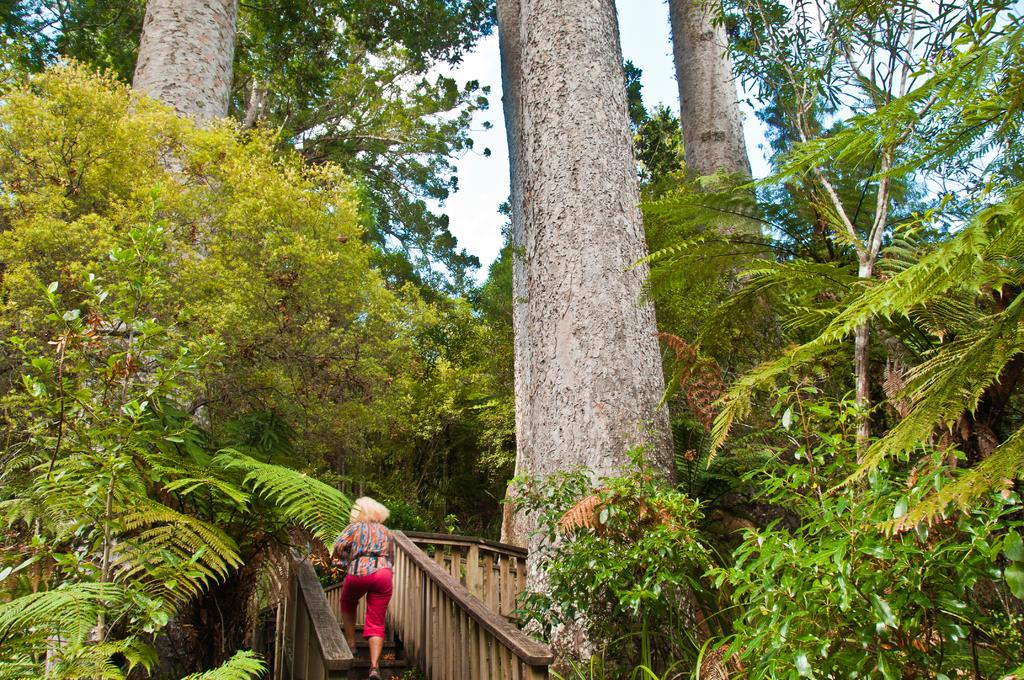What type of natural elements can be seen in the image? There are trees in the image. What is the woman in the image doing? The woman is climbing wooden stairs in the image. How would you describe the weather in the image? The sky is cloudy in the image. What type of money can be seen in the woman's hand in the image? There is no money visible in the image; the woman is climbing wooden stairs. What type of ship is present in the image? There is no ship present in the image; it features trees and a woman climbing wooden stairs. 